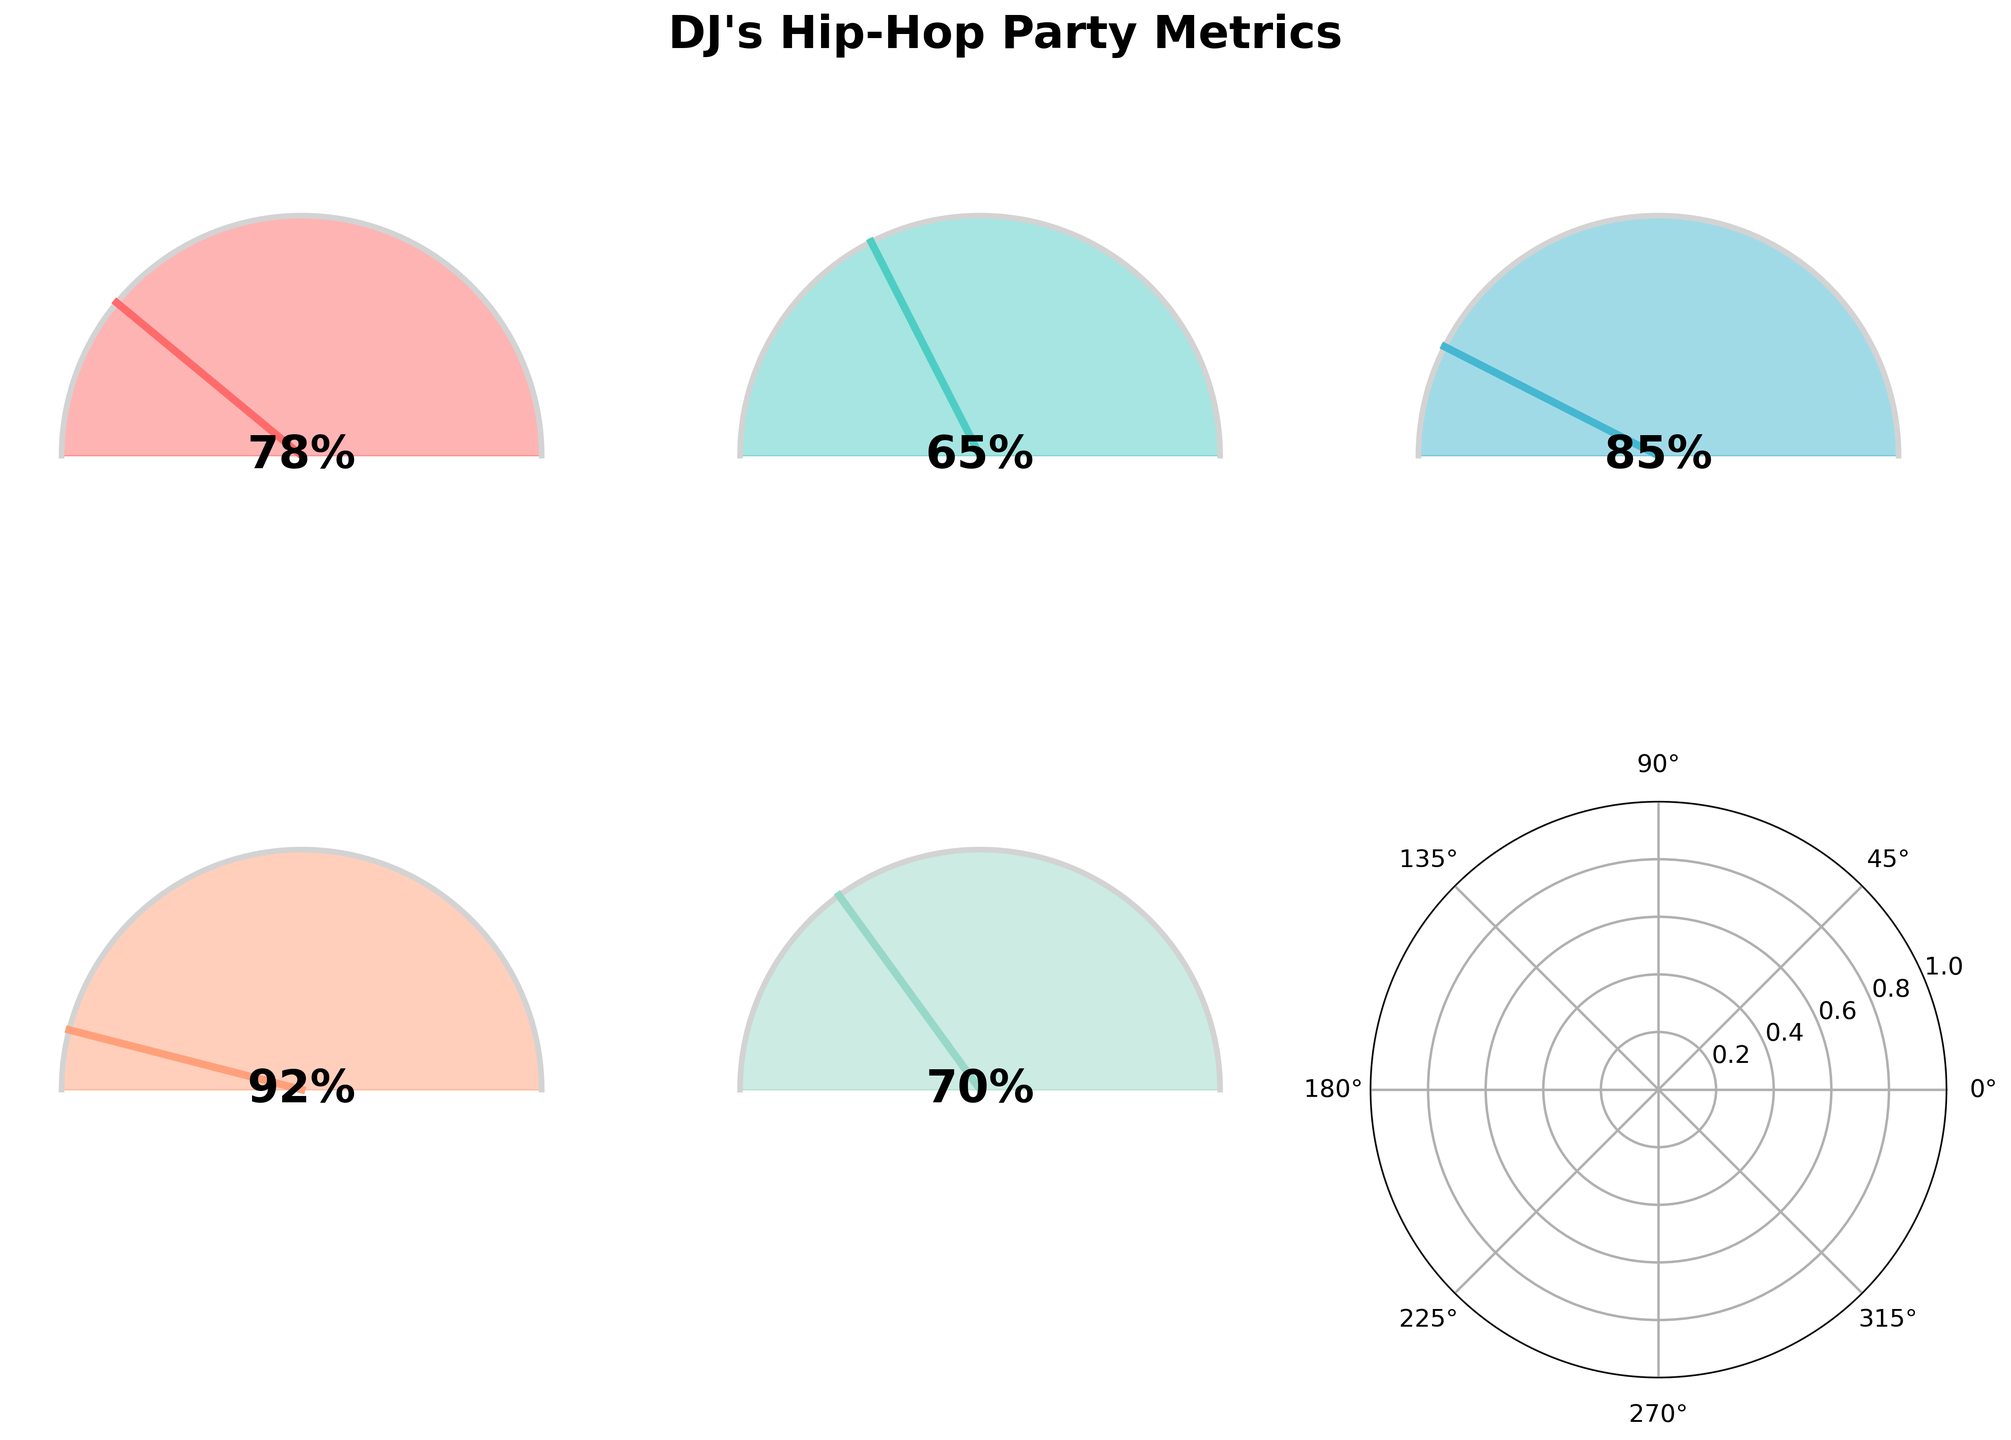What is the title of the figure? The title of the figure is generally the text written prominently at the top of the figure. In this case, it's "DJ's Hip-Hop Party Metrics" as indicated in the code.
Answer: DJ's Hip-Hop Party Metrics Which category has the highest percentage of song requests fulfilled? To find this, compare the percentages listed in all the gauge charts. The highest percentage is 92% under "Italian Artist Requests (%)".
Answer: Italian Artist Requests (%) How many categories are displayed in the figure excluding any empty subplots? Count the individual gauge charts displayed in the figure. The code indicates there are 2 rows with 3 subplots each, but the last subplot is empty, so there are 5 displayed categories.
Answer: 5 What is the range of the percentages shown in the charts? Identify the minimum and maximum percentages among all the gauge charts. The minimum is 65% and the maximum is 92%.
Answer: 65% to 92% Which two categories have the closest percentage values? Compare the percentages: 78%, 65%, 85%, 92%, and 70%. The closest are "Song Requests Fulfilled (%)" and "International Artist Requests (%)" with 78% and 70%, respectively.
Answer: Song Requests Fulfilled (%) and International Artist Requests (%) What is the average percentage of fulfilled requests across all categories? Add the percentages: 78, 65, 85, 92, and 70, then divide by the number of categories (5). (78 + 65 + 85 + 92 + 70) / 5 = 78
Answer: 78% What is the difference in percentage between "Hip-Hop Classics Requests (%)" and "Contemporary Hip-Hop Requests (%)"? Subtract the percentage of "Hip-Hop Classics Requests (%)" from "Contemporary Hip-Hop Requests (%)": 85% - 65% = 20%
Answer: 20% Which category has the lowest percentage of requests fulfilled? Find the lowest percentage among all gauge charts, which is 65% for "Hip-Hop Classics Requests (%)".
Answer: Hip-Hop Classics Requests (%) How does the percentage of "Italian Artist Requests (%)" compare to the average of all other categories? Calculate the average of the other four categories: (78 + 65 + 85 + 70) / 4 = 74.5%, then compare to 92%. "Italian Artist Requests (%)" is higher at 92%.
Answer: Higher What color is used for "Contemporary Hip-Hop Requests (%)"? From the code, the colors are in order. "Contemporary Hip-Hop Requests (%)" is the third chart and the corresponding third color is a shade of blue.
Answer: Blue 